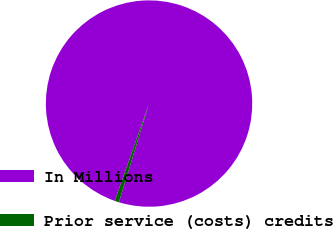Convert chart. <chart><loc_0><loc_0><loc_500><loc_500><pie_chart><fcel>In Millions<fcel>Prior service (costs) credits<nl><fcel>99.32%<fcel>0.68%<nl></chart> 